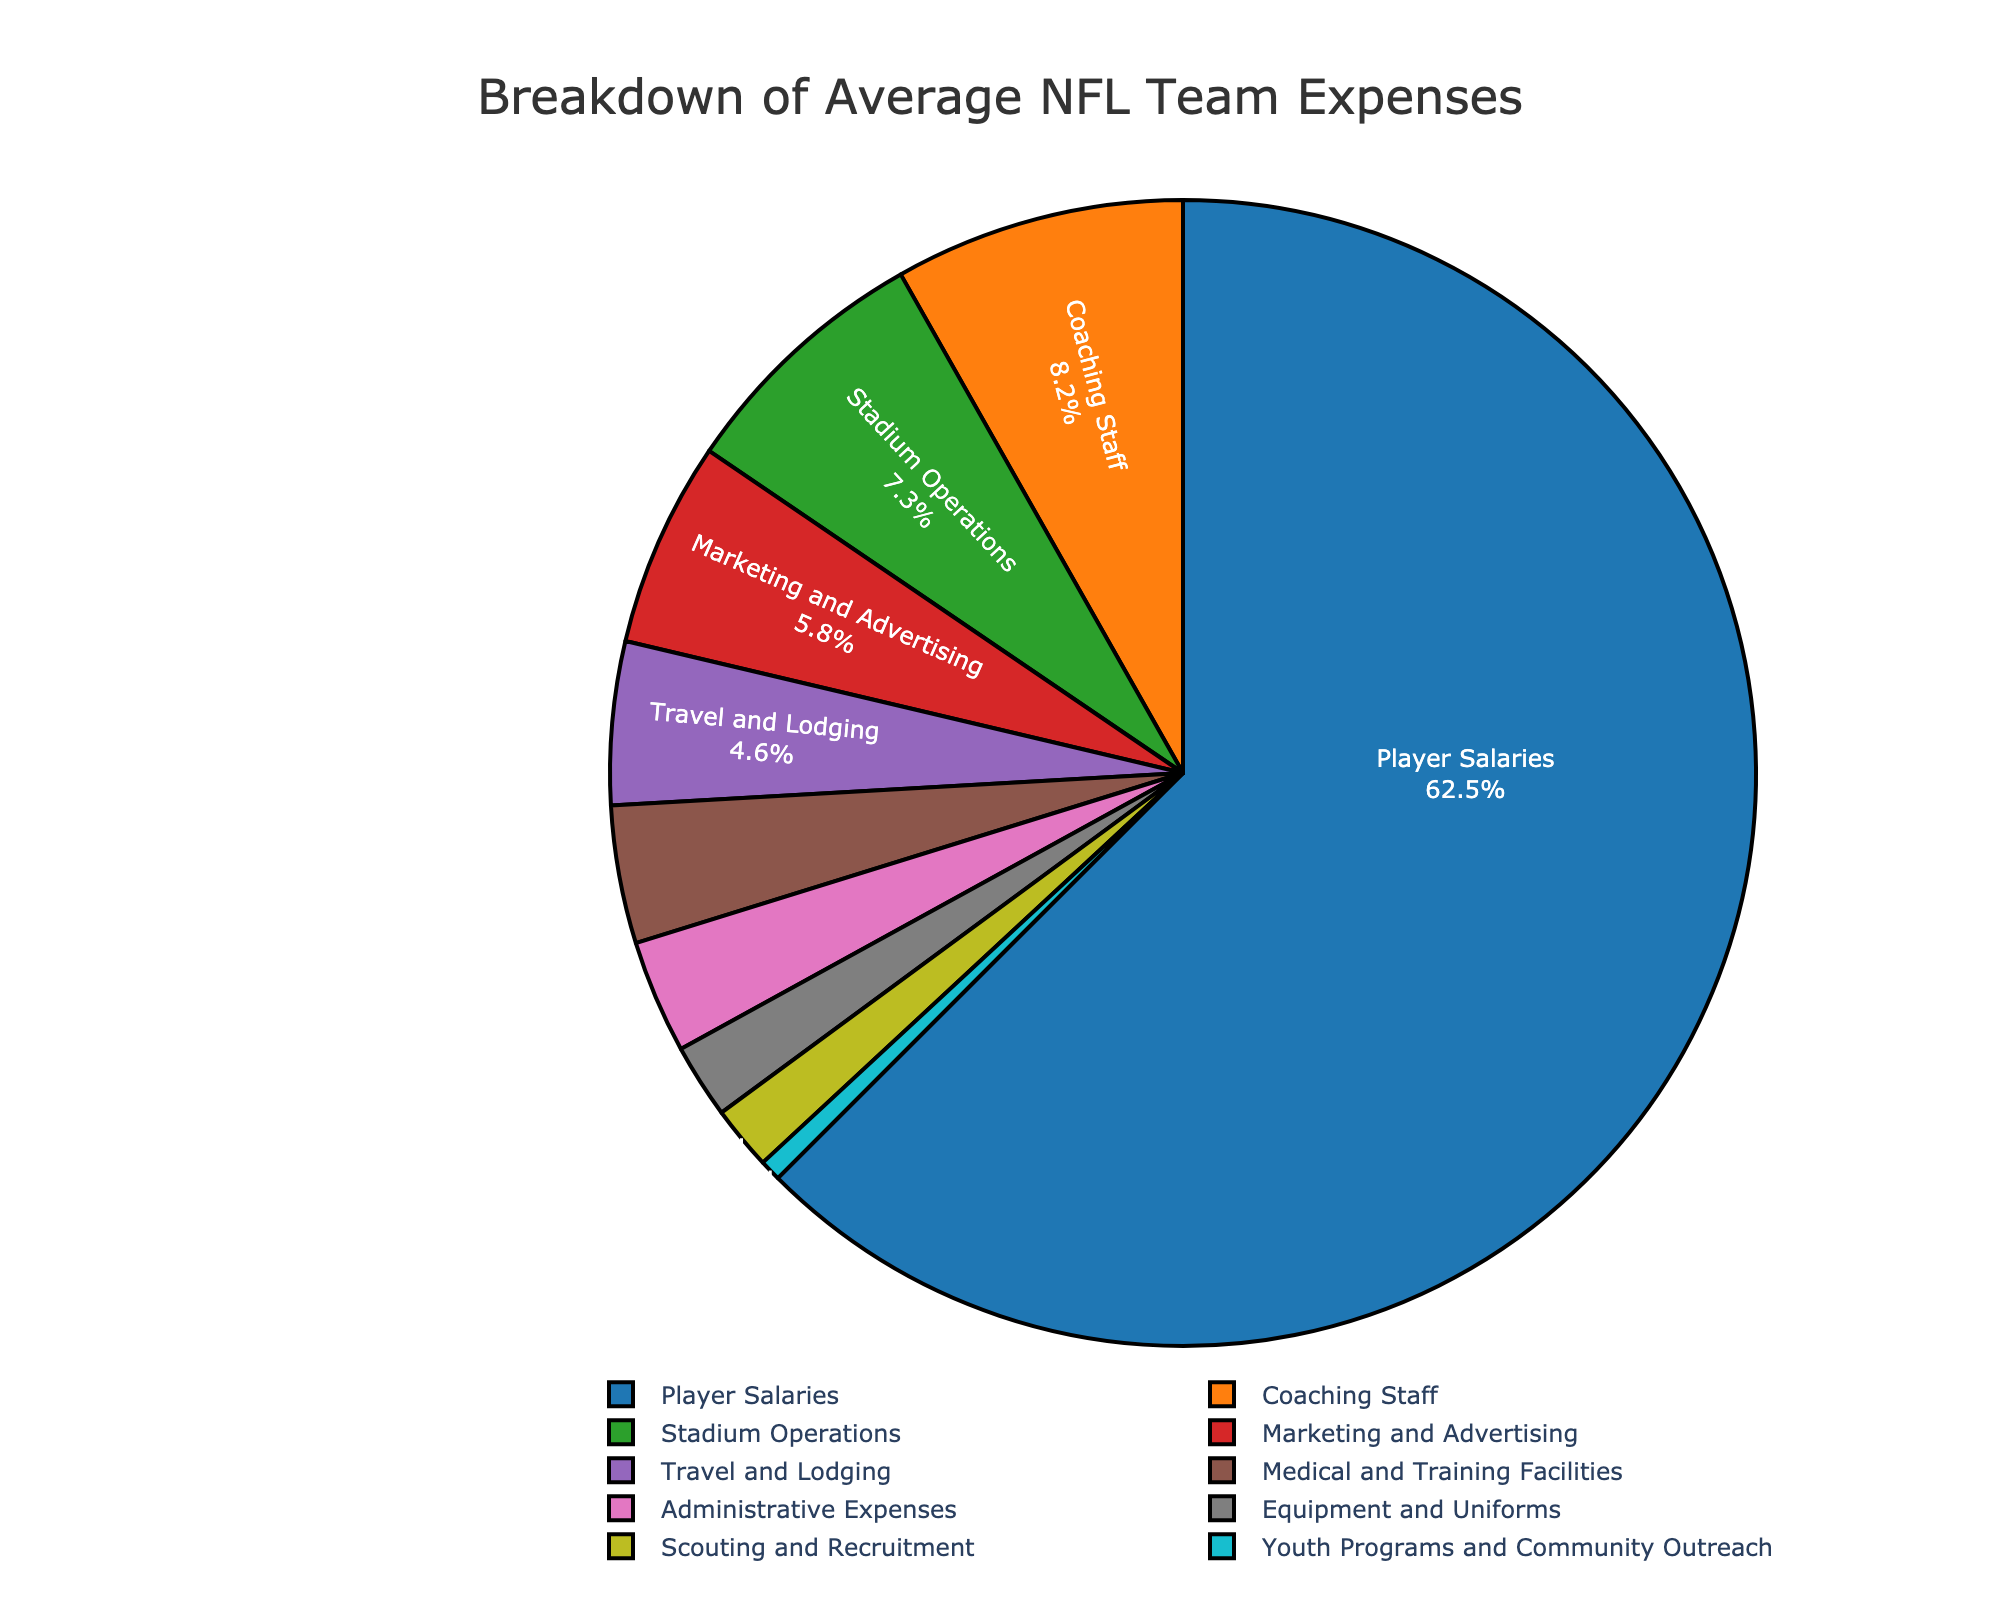What percentage of the total expenses is spent on Player Salaries and Coaching Staff combined? Player Salaries account for 62.5% and Coaching Staff account for 8.2%. By adding these two percentages, we get 62.5 + 8.2 = 70.7%.
Answer: 70.7% How much higher is the percentage spent on Player Salaries compared to Stadium Operations? The percentage spent on Player Salaries is 62.5%, and the percentage spent on Stadium Operations is 7.3%. The difference is 62.5 - 7.3 = 55.2%.
Answer: 55.2% What is the combined percentage of Marketing and Advertising, and Medical and Training Facilities? Marketing and Advertising account for 5.8%, and Medical and Training Facilities account for 3.9%. Summing these percentages, we get 5.8 + 3.9 = 9.7%.
Answer: 9.7% Which expense category has the second highest percentage? The expense category with the second highest percentage is Coaching Staff with 8.2%, just after Player Salaries with 62.5%.
Answer: Coaching Staff By how much does Travel and Lodging's percentage exceed Equipment and Uniforms' percentage? Travel and Lodging accounts for 4.6%, and Equipment and Uniforms account for 2.1%. The difference is 4.6 - 2.1 = 2.5%.
Answer: 2.5% What is the total percentage of expenses for Scouting and Recruitment, and Youth Programs and Community Outreach combined? Scouting and Recruitment account for 1.8%, and Youth Programs and Community Outreach account for 0.6%. Summing these percentages, we get 1.8 + 0.6 = 2.4%.
Answer: 2.4% Which category's expenses are depicted in green in the pie chart? The pie chart uses color coding, and the category depicted in green is Stadium Operations.
Answer: Stadium Operations How many categories have expense percentages less than 5%? The categories with percentages less than 5% are Travel and Lodging (4.6%), Medical and Training Facilities (3.9%), Administrative Expenses (3.2%), Equipment and Uniforms (2.1%), Scouting and Recruitment (1.8%), and Youth Programs and Community Outreach (0.6%). This makes a total of 6 categories.
Answer: 6 What is the average percentage expenditure for the categories that spend more than 5%? Categories with expenses more than 5% are Player Salaries (62.5%), Coaching Staff (8.2%), and Marketing and Advertising (5.8%). Calculate the average by summing them up and dividing by the number of categories: (62.5 + 8.2 + 5.8) / 3 = 76.5 / 3 = 25.5%.
Answer: 25.5% What is the difference in percentage between the highest and the lowest expense categories? The highest expense category is Player Salaries at 62.5%, and the lowest is Youth Programs and Community Outreach at 0.6%. The difference is 62.5 - 0.6 = 61.9%.
Answer: 61.9% 